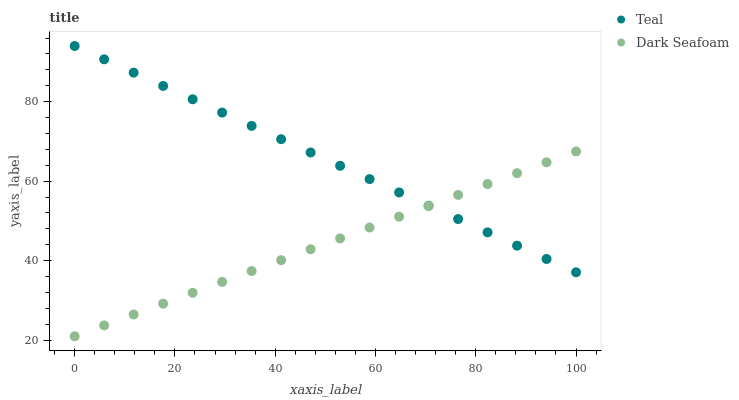Does Dark Seafoam have the minimum area under the curve?
Answer yes or no. Yes. Does Teal have the maximum area under the curve?
Answer yes or no. Yes. Does Teal have the minimum area under the curve?
Answer yes or no. No. Is Dark Seafoam the smoothest?
Answer yes or no. Yes. Is Teal the roughest?
Answer yes or no. Yes. Is Teal the smoothest?
Answer yes or no. No. Does Dark Seafoam have the lowest value?
Answer yes or no. Yes. Does Teal have the lowest value?
Answer yes or no. No. Does Teal have the highest value?
Answer yes or no. Yes. Does Dark Seafoam intersect Teal?
Answer yes or no. Yes. Is Dark Seafoam less than Teal?
Answer yes or no. No. Is Dark Seafoam greater than Teal?
Answer yes or no. No. 